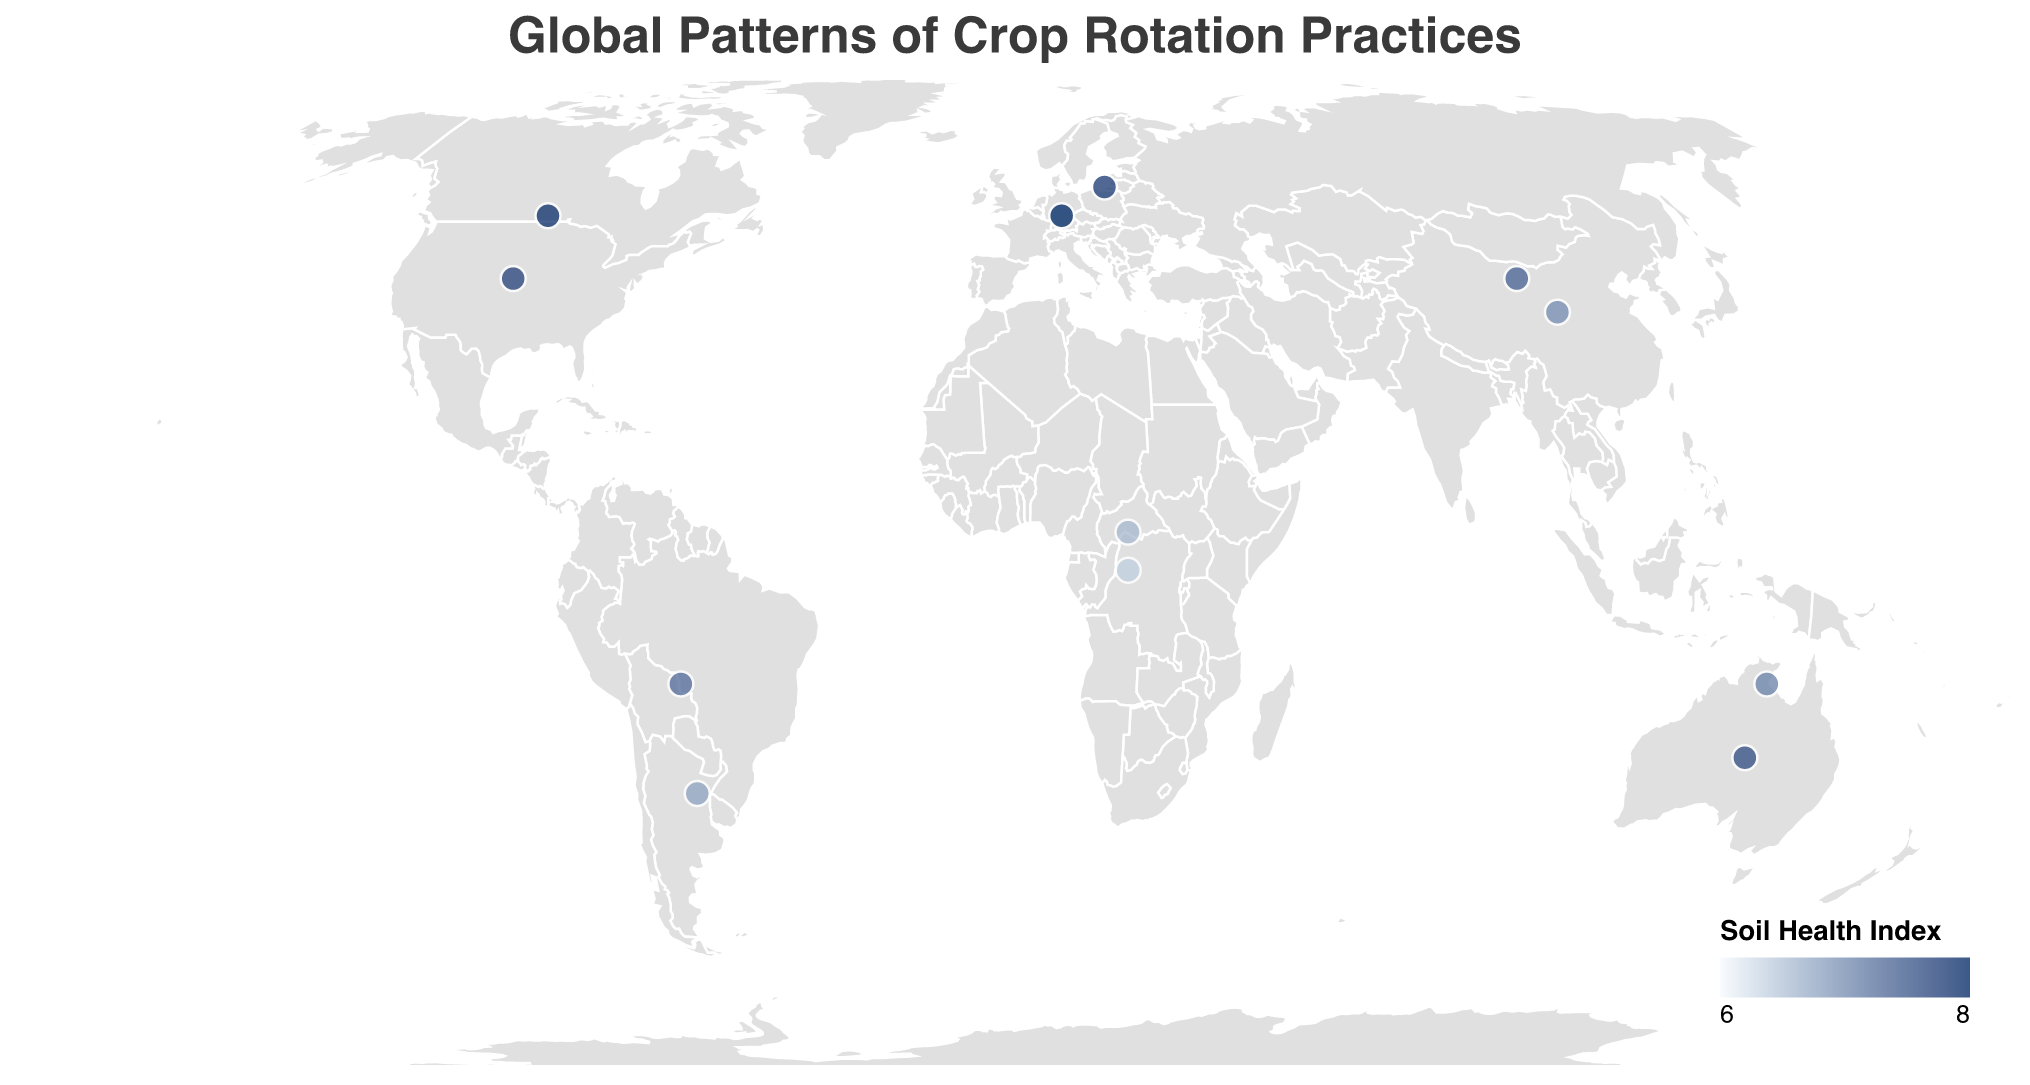What's the title of the figure? The title is often prominently displayed at the top of the figure. In this case, it reads "Global Patterns of Crop Rotation Practices".
Answer: Global Patterns of Crop Rotation Practices What's the range of the Soil Health Index represented in the color legend? The color legend shows the range of values for the Soil Health Index. The minimum value is represented by a lighter color and the maximum by a darker color. Here, the range is from 5.5 to 7.5.
Answer: 5.5 to 7.5 Which climate zone in Asia has the highest Soil Health Index? By observing the color on the map corresponding to the climate zones in Asia, one can identify the darkest shade, which represents the highest Soil Health Index. Asia's temperate zone has a Soil Health Index of 6.9.
Answer: Temperate Which continent has the lowest Soil Health Index for a tropical climate zone? The figure uses different shades to indicate Soil Health Index values for each region. By comparing the tropical zones across continents, Africa is the lightest in color, indicating a Soil Health Index of 6.1.
Answer: Africa What is the primary rotation practice in Europe’s Mediterranean climate zone? The tooltip shows "Primary Rotation Practice" for each data point. In Europe’s Mediterranean climate zone, it is "Wheat-Sunflower."
Answer: Wheat-Sunflower Compare the Rotation Frequency of Subtropical zones in South America and Asia. The figure provides "Rotation Frequency" as part of the tooltip. For South America, the frequency is 2-3 years, and for Asia, it is 1-2 years.
Answer: South America: 2-3 years, Asia: 1-2 years What are the primary and secondary rotation practices in Oceania’s tropical climate zone? The tooltip provides detailed rotation practices for each location. In Oceania’s tropical climate zone, they are "Sugarcane-Legumes" and "Maize-Peanut."
Answer: Primary: Sugarcane-Legumes, Secondary: Maize-Peanut Which continent has the greatest variation in rotation frequency? By examining the tooltip details for each continent, one can determine that Asia shows rotation frequencies ranging from 1-2 years in the subtropical zone to 2-3 years in the temperate zone, thus indicating the greatest variation.
Answer: Asia Calculate the average Soil Health Index for temperate zones in North America and Oceania. North America’s temperate zone has a Soil Health Index of 7.2, and Oceania’s has 7.1. The average is calculated as (7.2 + 7.1) / 2 = 7.15.
Answer: 7.15 